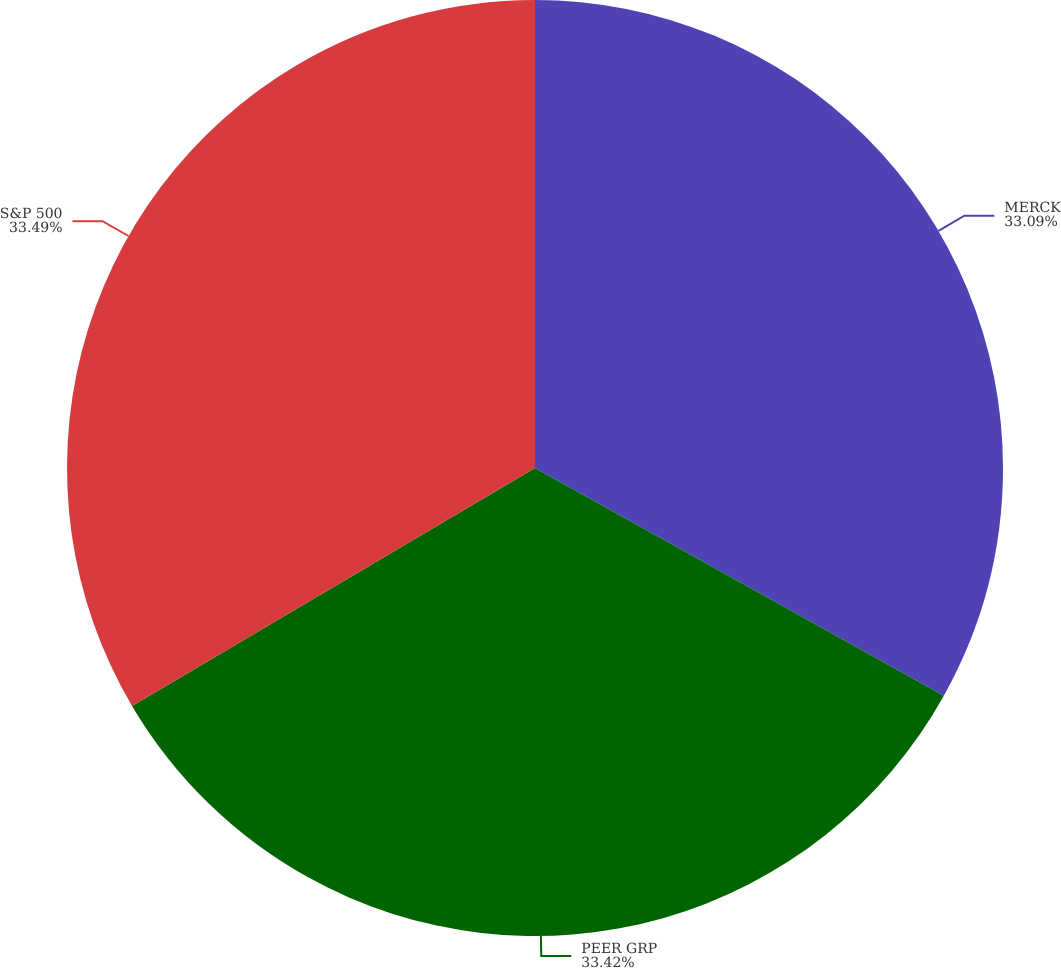<chart> <loc_0><loc_0><loc_500><loc_500><pie_chart><fcel>MERCK<fcel>PEER GRP<fcel>S&P 500<nl><fcel>33.09%<fcel>33.42%<fcel>33.49%<nl></chart> 